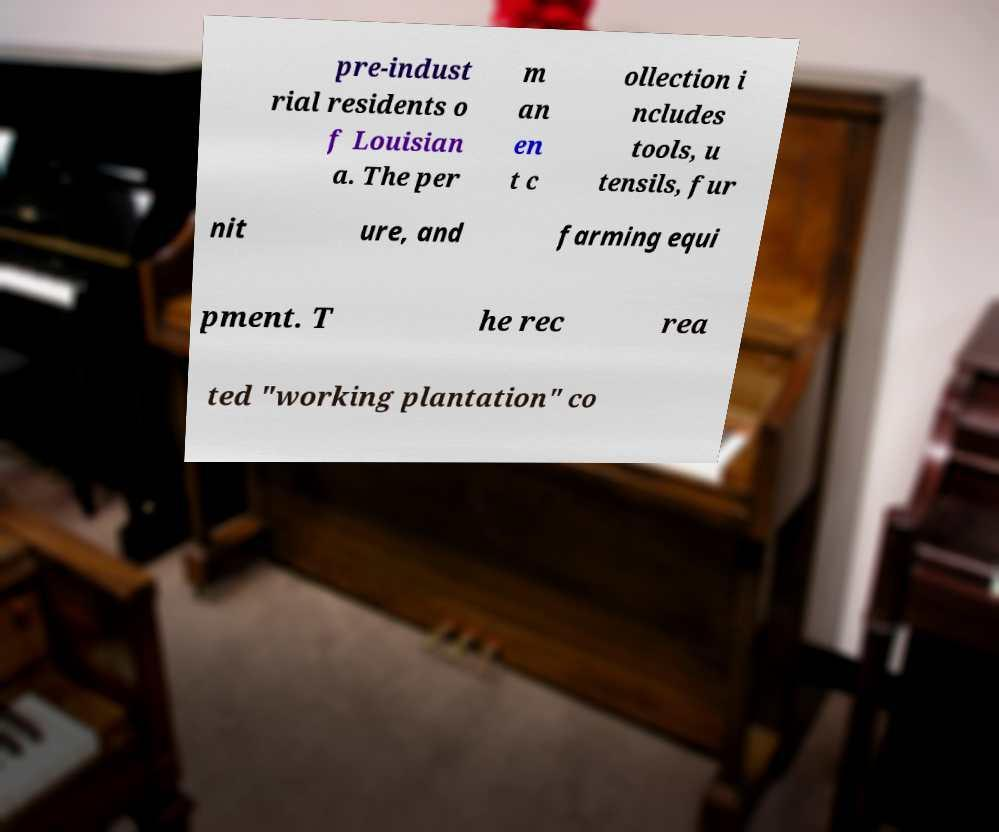Could you assist in decoding the text presented in this image and type it out clearly? pre-indust rial residents o f Louisian a. The per m an en t c ollection i ncludes tools, u tensils, fur nit ure, and farming equi pment. T he rec rea ted "working plantation" co 